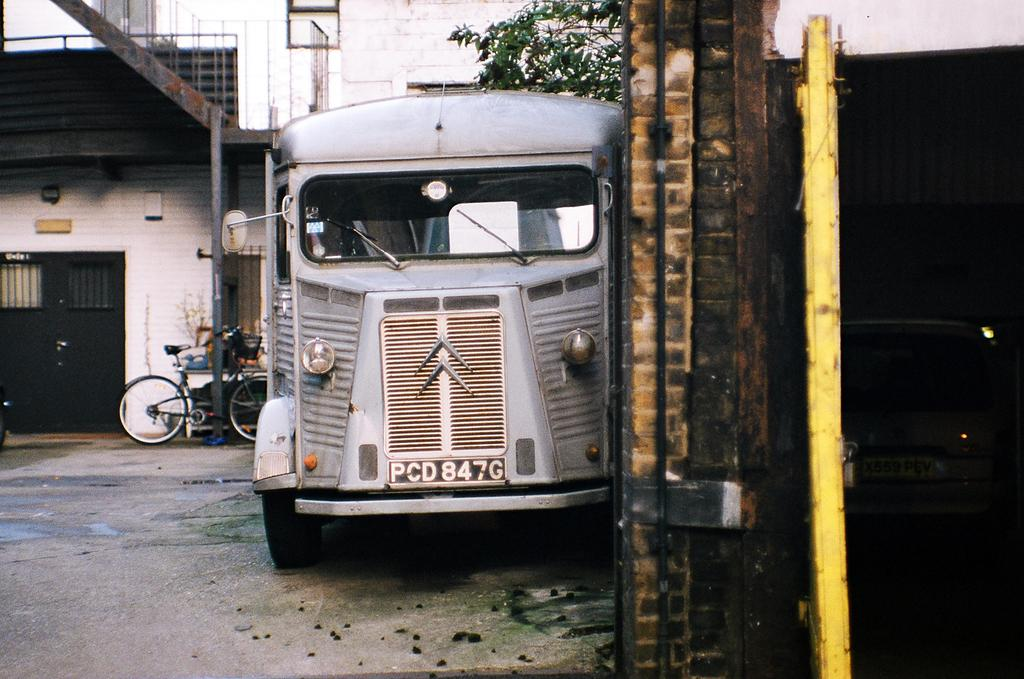What types of objects are present in the image? There are vehicles in the image. Can you describe one of the vehicles? One of the vehicles is white. What can be seen in the background of the image? There is a building and plants in the background of the image. What color is the building? The building is white. What color are the plants? The plants are green. What else is visible in the background of the image? The sky is visible in the background of the image. What type of stone is being used to whip the vehicles in the image? There is no stone or whipping action present in the image; it features vehicles, a building, plants, and the sky. 